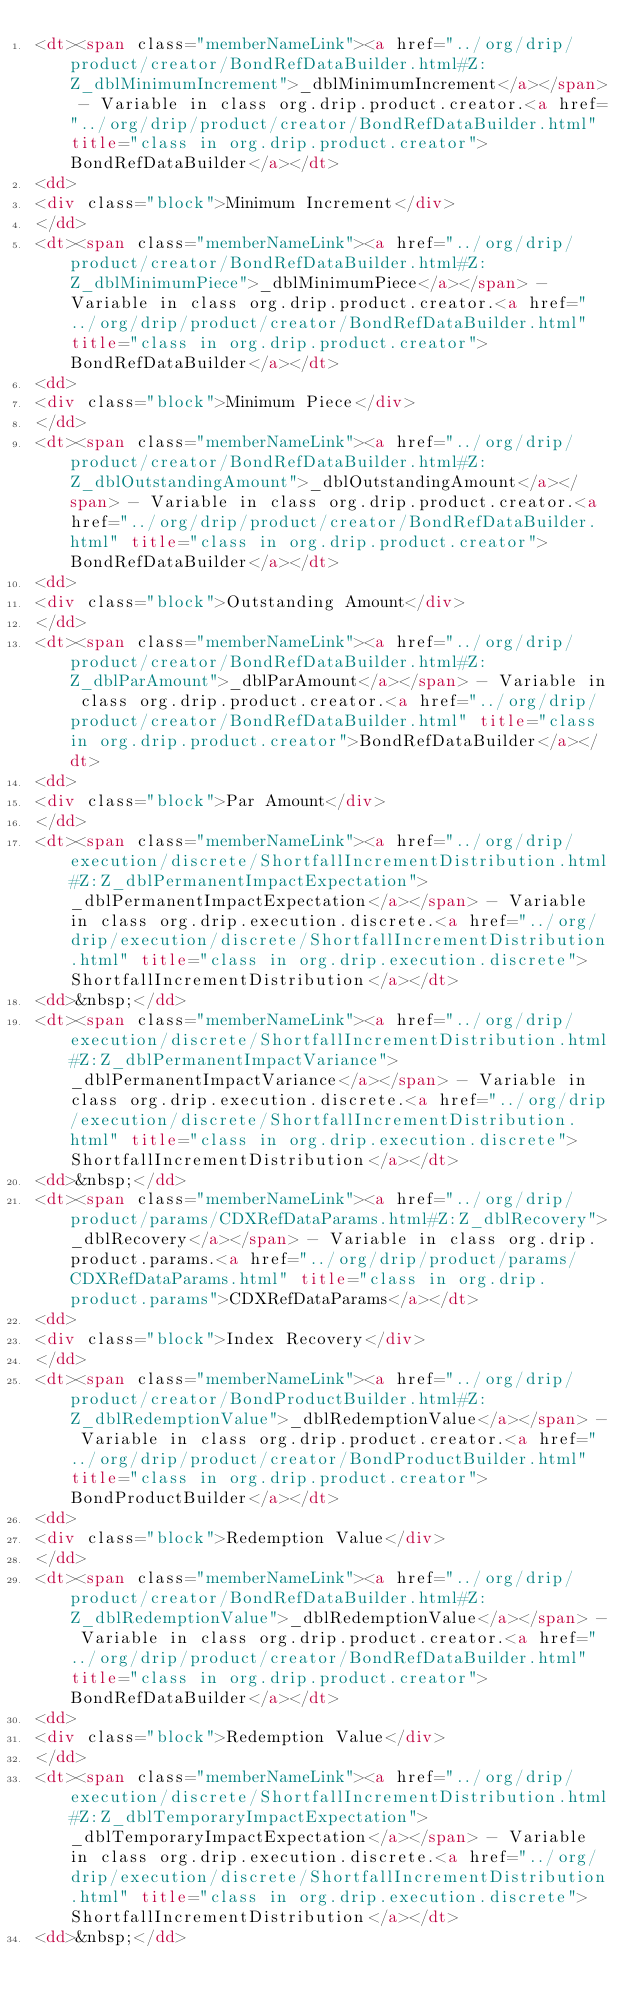Convert code to text. <code><loc_0><loc_0><loc_500><loc_500><_HTML_><dt><span class="memberNameLink"><a href="../org/drip/product/creator/BondRefDataBuilder.html#Z:Z_dblMinimumIncrement">_dblMinimumIncrement</a></span> - Variable in class org.drip.product.creator.<a href="../org/drip/product/creator/BondRefDataBuilder.html" title="class in org.drip.product.creator">BondRefDataBuilder</a></dt>
<dd>
<div class="block">Minimum Increment</div>
</dd>
<dt><span class="memberNameLink"><a href="../org/drip/product/creator/BondRefDataBuilder.html#Z:Z_dblMinimumPiece">_dblMinimumPiece</a></span> - Variable in class org.drip.product.creator.<a href="../org/drip/product/creator/BondRefDataBuilder.html" title="class in org.drip.product.creator">BondRefDataBuilder</a></dt>
<dd>
<div class="block">Minimum Piece</div>
</dd>
<dt><span class="memberNameLink"><a href="../org/drip/product/creator/BondRefDataBuilder.html#Z:Z_dblOutstandingAmount">_dblOutstandingAmount</a></span> - Variable in class org.drip.product.creator.<a href="../org/drip/product/creator/BondRefDataBuilder.html" title="class in org.drip.product.creator">BondRefDataBuilder</a></dt>
<dd>
<div class="block">Outstanding Amount</div>
</dd>
<dt><span class="memberNameLink"><a href="../org/drip/product/creator/BondRefDataBuilder.html#Z:Z_dblParAmount">_dblParAmount</a></span> - Variable in class org.drip.product.creator.<a href="../org/drip/product/creator/BondRefDataBuilder.html" title="class in org.drip.product.creator">BondRefDataBuilder</a></dt>
<dd>
<div class="block">Par Amount</div>
</dd>
<dt><span class="memberNameLink"><a href="../org/drip/execution/discrete/ShortfallIncrementDistribution.html#Z:Z_dblPermanentImpactExpectation">_dblPermanentImpactExpectation</a></span> - Variable in class org.drip.execution.discrete.<a href="../org/drip/execution/discrete/ShortfallIncrementDistribution.html" title="class in org.drip.execution.discrete">ShortfallIncrementDistribution</a></dt>
<dd>&nbsp;</dd>
<dt><span class="memberNameLink"><a href="../org/drip/execution/discrete/ShortfallIncrementDistribution.html#Z:Z_dblPermanentImpactVariance">_dblPermanentImpactVariance</a></span> - Variable in class org.drip.execution.discrete.<a href="../org/drip/execution/discrete/ShortfallIncrementDistribution.html" title="class in org.drip.execution.discrete">ShortfallIncrementDistribution</a></dt>
<dd>&nbsp;</dd>
<dt><span class="memberNameLink"><a href="../org/drip/product/params/CDXRefDataParams.html#Z:Z_dblRecovery">_dblRecovery</a></span> - Variable in class org.drip.product.params.<a href="../org/drip/product/params/CDXRefDataParams.html" title="class in org.drip.product.params">CDXRefDataParams</a></dt>
<dd>
<div class="block">Index Recovery</div>
</dd>
<dt><span class="memberNameLink"><a href="../org/drip/product/creator/BondProductBuilder.html#Z:Z_dblRedemptionValue">_dblRedemptionValue</a></span> - Variable in class org.drip.product.creator.<a href="../org/drip/product/creator/BondProductBuilder.html" title="class in org.drip.product.creator">BondProductBuilder</a></dt>
<dd>
<div class="block">Redemption Value</div>
</dd>
<dt><span class="memberNameLink"><a href="../org/drip/product/creator/BondRefDataBuilder.html#Z:Z_dblRedemptionValue">_dblRedemptionValue</a></span> - Variable in class org.drip.product.creator.<a href="../org/drip/product/creator/BondRefDataBuilder.html" title="class in org.drip.product.creator">BondRefDataBuilder</a></dt>
<dd>
<div class="block">Redemption Value</div>
</dd>
<dt><span class="memberNameLink"><a href="../org/drip/execution/discrete/ShortfallIncrementDistribution.html#Z:Z_dblTemporaryImpactExpectation">_dblTemporaryImpactExpectation</a></span> - Variable in class org.drip.execution.discrete.<a href="../org/drip/execution/discrete/ShortfallIncrementDistribution.html" title="class in org.drip.execution.discrete">ShortfallIncrementDistribution</a></dt>
<dd>&nbsp;</dd></code> 